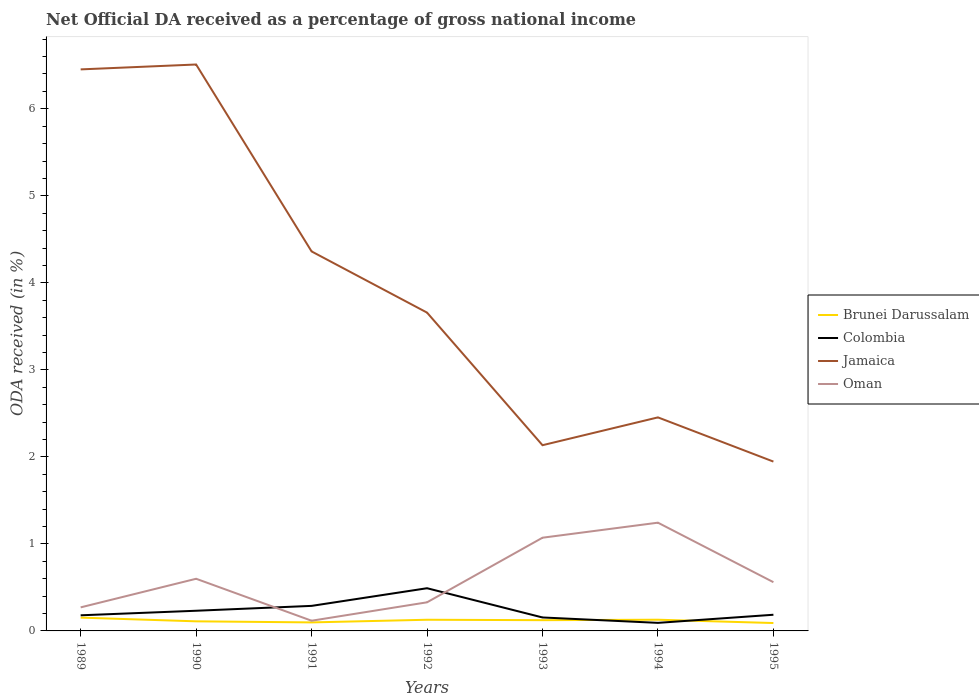How many different coloured lines are there?
Keep it short and to the point. 4. Does the line corresponding to Jamaica intersect with the line corresponding to Colombia?
Your answer should be very brief. No. Across all years, what is the maximum net official DA received in Jamaica?
Provide a succinct answer. 1.95. What is the total net official DA received in Jamaica in the graph?
Offer a terse response. 1.2. What is the difference between the highest and the second highest net official DA received in Brunei Darussalam?
Your answer should be compact. 0.06. What is the difference between the highest and the lowest net official DA received in Brunei Darussalam?
Your answer should be very brief. 4. How many lines are there?
Your answer should be very brief. 4. Does the graph contain any zero values?
Your response must be concise. No. Where does the legend appear in the graph?
Offer a terse response. Center right. What is the title of the graph?
Your answer should be very brief. Net Official DA received as a percentage of gross national income. Does "Armenia" appear as one of the legend labels in the graph?
Give a very brief answer. No. What is the label or title of the Y-axis?
Your response must be concise. ODA received (in %). What is the ODA received (in %) of Brunei Darussalam in 1989?
Your answer should be very brief. 0.15. What is the ODA received (in %) in Colombia in 1989?
Make the answer very short. 0.18. What is the ODA received (in %) in Jamaica in 1989?
Ensure brevity in your answer.  6.45. What is the ODA received (in %) of Oman in 1989?
Provide a succinct answer. 0.27. What is the ODA received (in %) of Brunei Darussalam in 1990?
Give a very brief answer. 0.11. What is the ODA received (in %) in Colombia in 1990?
Ensure brevity in your answer.  0.23. What is the ODA received (in %) in Jamaica in 1990?
Provide a short and direct response. 6.51. What is the ODA received (in %) of Oman in 1990?
Your response must be concise. 0.6. What is the ODA received (in %) in Brunei Darussalam in 1991?
Your answer should be compact. 0.1. What is the ODA received (in %) of Colombia in 1991?
Your response must be concise. 0.29. What is the ODA received (in %) in Jamaica in 1991?
Your answer should be very brief. 4.36. What is the ODA received (in %) in Oman in 1991?
Give a very brief answer. 0.12. What is the ODA received (in %) of Brunei Darussalam in 1992?
Keep it short and to the point. 0.13. What is the ODA received (in %) of Colombia in 1992?
Your response must be concise. 0.49. What is the ODA received (in %) of Jamaica in 1992?
Give a very brief answer. 3.66. What is the ODA received (in %) in Oman in 1992?
Provide a succinct answer. 0.33. What is the ODA received (in %) in Brunei Darussalam in 1993?
Give a very brief answer. 0.12. What is the ODA received (in %) of Colombia in 1993?
Make the answer very short. 0.15. What is the ODA received (in %) of Jamaica in 1993?
Offer a terse response. 2.13. What is the ODA received (in %) of Oman in 1993?
Provide a short and direct response. 1.07. What is the ODA received (in %) in Brunei Darussalam in 1994?
Offer a terse response. 0.13. What is the ODA received (in %) in Colombia in 1994?
Offer a very short reply. 0.09. What is the ODA received (in %) of Jamaica in 1994?
Your response must be concise. 2.45. What is the ODA received (in %) in Oman in 1994?
Your response must be concise. 1.24. What is the ODA received (in %) in Brunei Darussalam in 1995?
Keep it short and to the point. 0.09. What is the ODA received (in %) of Colombia in 1995?
Your response must be concise. 0.19. What is the ODA received (in %) of Jamaica in 1995?
Provide a succinct answer. 1.95. What is the ODA received (in %) in Oman in 1995?
Offer a very short reply. 0.56. Across all years, what is the maximum ODA received (in %) in Brunei Darussalam?
Offer a very short reply. 0.15. Across all years, what is the maximum ODA received (in %) of Colombia?
Offer a very short reply. 0.49. Across all years, what is the maximum ODA received (in %) in Jamaica?
Ensure brevity in your answer.  6.51. Across all years, what is the maximum ODA received (in %) in Oman?
Your response must be concise. 1.24. Across all years, what is the minimum ODA received (in %) in Brunei Darussalam?
Offer a very short reply. 0.09. Across all years, what is the minimum ODA received (in %) of Colombia?
Ensure brevity in your answer.  0.09. Across all years, what is the minimum ODA received (in %) in Jamaica?
Provide a succinct answer. 1.95. Across all years, what is the minimum ODA received (in %) in Oman?
Keep it short and to the point. 0.12. What is the total ODA received (in %) of Brunei Darussalam in the graph?
Ensure brevity in your answer.  0.83. What is the total ODA received (in %) of Colombia in the graph?
Give a very brief answer. 1.62. What is the total ODA received (in %) in Jamaica in the graph?
Your answer should be very brief. 27.51. What is the total ODA received (in %) of Oman in the graph?
Ensure brevity in your answer.  4.19. What is the difference between the ODA received (in %) of Brunei Darussalam in 1989 and that in 1990?
Your answer should be compact. 0.04. What is the difference between the ODA received (in %) in Colombia in 1989 and that in 1990?
Offer a very short reply. -0.05. What is the difference between the ODA received (in %) in Jamaica in 1989 and that in 1990?
Provide a succinct answer. -0.06. What is the difference between the ODA received (in %) in Oman in 1989 and that in 1990?
Keep it short and to the point. -0.33. What is the difference between the ODA received (in %) in Brunei Darussalam in 1989 and that in 1991?
Offer a terse response. 0.05. What is the difference between the ODA received (in %) of Colombia in 1989 and that in 1991?
Keep it short and to the point. -0.11. What is the difference between the ODA received (in %) of Jamaica in 1989 and that in 1991?
Offer a very short reply. 2.09. What is the difference between the ODA received (in %) in Oman in 1989 and that in 1991?
Keep it short and to the point. 0.15. What is the difference between the ODA received (in %) of Brunei Darussalam in 1989 and that in 1992?
Offer a terse response. 0.02. What is the difference between the ODA received (in %) of Colombia in 1989 and that in 1992?
Keep it short and to the point. -0.31. What is the difference between the ODA received (in %) in Jamaica in 1989 and that in 1992?
Ensure brevity in your answer.  2.79. What is the difference between the ODA received (in %) of Oman in 1989 and that in 1992?
Your answer should be very brief. -0.06. What is the difference between the ODA received (in %) in Brunei Darussalam in 1989 and that in 1993?
Keep it short and to the point. 0.03. What is the difference between the ODA received (in %) of Colombia in 1989 and that in 1993?
Provide a short and direct response. 0.02. What is the difference between the ODA received (in %) of Jamaica in 1989 and that in 1993?
Your response must be concise. 4.32. What is the difference between the ODA received (in %) of Oman in 1989 and that in 1993?
Your response must be concise. -0.8. What is the difference between the ODA received (in %) in Brunei Darussalam in 1989 and that in 1994?
Ensure brevity in your answer.  0.02. What is the difference between the ODA received (in %) of Colombia in 1989 and that in 1994?
Your answer should be compact. 0.09. What is the difference between the ODA received (in %) in Jamaica in 1989 and that in 1994?
Provide a short and direct response. 4. What is the difference between the ODA received (in %) of Oman in 1989 and that in 1994?
Provide a short and direct response. -0.97. What is the difference between the ODA received (in %) in Brunei Darussalam in 1989 and that in 1995?
Provide a short and direct response. 0.06. What is the difference between the ODA received (in %) in Colombia in 1989 and that in 1995?
Your answer should be compact. -0.01. What is the difference between the ODA received (in %) of Jamaica in 1989 and that in 1995?
Offer a very short reply. 4.51. What is the difference between the ODA received (in %) of Oman in 1989 and that in 1995?
Ensure brevity in your answer.  -0.29. What is the difference between the ODA received (in %) in Brunei Darussalam in 1990 and that in 1991?
Provide a succinct answer. 0.01. What is the difference between the ODA received (in %) of Colombia in 1990 and that in 1991?
Your answer should be compact. -0.06. What is the difference between the ODA received (in %) of Jamaica in 1990 and that in 1991?
Keep it short and to the point. 2.15. What is the difference between the ODA received (in %) of Oman in 1990 and that in 1991?
Your answer should be compact. 0.48. What is the difference between the ODA received (in %) of Brunei Darussalam in 1990 and that in 1992?
Give a very brief answer. -0.02. What is the difference between the ODA received (in %) in Colombia in 1990 and that in 1992?
Your response must be concise. -0.26. What is the difference between the ODA received (in %) of Jamaica in 1990 and that in 1992?
Your answer should be very brief. 2.85. What is the difference between the ODA received (in %) in Oman in 1990 and that in 1992?
Your response must be concise. 0.27. What is the difference between the ODA received (in %) of Brunei Darussalam in 1990 and that in 1993?
Ensure brevity in your answer.  -0.01. What is the difference between the ODA received (in %) of Colombia in 1990 and that in 1993?
Offer a very short reply. 0.08. What is the difference between the ODA received (in %) of Jamaica in 1990 and that in 1993?
Your response must be concise. 4.37. What is the difference between the ODA received (in %) in Oman in 1990 and that in 1993?
Make the answer very short. -0.47. What is the difference between the ODA received (in %) of Brunei Darussalam in 1990 and that in 1994?
Make the answer very short. -0.02. What is the difference between the ODA received (in %) in Colombia in 1990 and that in 1994?
Your response must be concise. 0.14. What is the difference between the ODA received (in %) of Jamaica in 1990 and that in 1994?
Offer a very short reply. 4.06. What is the difference between the ODA received (in %) of Oman in 1990 and that in 1994?
Offer a terse response. -0.64. What is the difference between the ODA received (in %) of Brunei Darussalam in 1990 and that in 1995?
Provide a short and direct response. 0.02. What is the difference between the ODA received (in %) of Colombia in 1990 and that in 1995?
Offer a terse response. 0.05. What is the difference between the ODA received (in %) of Jamaica in 1990 and that in 1995?
Ensure brevity in your answer.  4.56. What is the difference between the ODA received (in %) in Oman in 1990 and that in 1995?
Make the answer very short. 0.04. What is the difference between the ODA received (in %) in Brunei Darussalam in 1991 and that in 1992?
Offer a very short reply. -0.03. What is the difference between the ODA received (in %) in Colombia in 1991 and that in 1992?
Your answer should be compact. -0.2. What is the difference between the ODA received (in %) of Jamaica in 1991 and that in 1992?
Your answer should be compact. 0.7. What is the difference between the ODA received (in %) in Oman in 1991 and that in 1992?
Your answer should be very brief. -0.21. What is the difference between the ODA received (in %) in Brunei Darussalam in 1991 and that in 1993?
Keep it short and to the point. -0.03. What is the difference between the ODA received (in %) of Colombia in 1991 and that in 1993?
Ensure brevity in your answer.  0.13. What is the difference between the ODA received (in %) in Jamaica in 1991 and that in 1993?
Your response must be concise. 2.23. What is the difference between the ODA received (in %) in Oman in 1991 and that in 1993?
Your response must be concise. -0.95. What is the difference between the ODA received (in %) of Brunei Darussalam in 1991 and that in 1994?
Offer a very short reply. -0.03. What is the difference between the ODA received (in %) in Colombia in 1991 and that in 1994?
Your answer should be compact. 0.2. What is the difference between the ODA received (in %) of Jamaica in 1991 and that in 1994?
Make the answer very short. 1.91. What is the difference between the ODA received (in %) in Oman in 1991 and that in 1994?
Provide a succinct answer. -1.13. What is the difference between the ODA received (in %) of Brunei Darussalam in 1991 and that in 1995?
Give a very brief answer. 0.01. What is the difference between the ODA received (in %) of Colombia in 1991 and that in 1995?
Offer a terse response. 0.1. What is the difference between the ODA received (in %) of Jamaica in 1991 and that in 1995?
Give a very brief answer. 2.42. What is the difference between the ODA received (in %) of Oman in 1991 and that in 1995?
Provide a succinct answer. -0.44. What is the difference between the ODA received (in %) of Brunei Darussalam in 1992 and that in 1993?
Provide a short and direct response. 0. What is the difference between the ODA received (in %) in Colombia in 1992 and that in 1993?
Your answer should be very brief. 0.34. What is the difference between the ODA received (in %) in Jamaica in 1992 and that in 1993?
Offer a very short reply. 1.52. What is the difference between the ODA received (in %) of Oman in 1992 and that in 1993?
Give a very brief answer. -0.74. What is the difference between the ODA received (in %) of Brunei Darussalam in 1992 and that in 1994?
Give a very brief answer. -0. What is the difference between the ODA received (in %) in Colombia in 1992 and that in 1994?
Give a very brief answer. 0.4. What is the difference between the ODA received (in %) of Jamaica in 1992 and that in 1994?
Your answer should be very brief. 1.2. What is the difference between the ODA received (in %) of Oman in 1992 and that in 1994?
Your response must be concise. -0.92. What is the difference between the ODA received (in %) of Brunei Darussalam in 1992 and that in 1995?
Provide a short and direct response. 0.04. What is the difference between the ODA received (in %) in Colombia in 1992 and that in 1995?
Provide a succinct answer. 0.3. What is the difference between the ODA received (in %) of Jamaica in 1992 and that in 1995?
Make the answer very short. 1.71. What is the difference between the ODA received (in %) of Oman in 1992 and that in 1995?
Your answer should be compact. -0.23. What is the difference between the ODA received (in %) of Brunei Darussalam in 1993 and that in 1994?
Your answer should be compact. -0.01. What is the difference between the ODA received (in %) of Colombia in 1993 and that in 1994?
Make the answer very short. 0.06. What is the difference between the ODA received (in %) in Jamaica in 1993 and that in 1994?
Provide a short and direct response. -0.32. What is the difference between the ODA received (in %) in Oman in 1993 and that in 1994?
Keep it short and to the point. -0.17. What is the difference between the ODA received (in %) of Brunei Darussalam in 1993 and that in 1995?
Your response must be concise. 0.03. What is the difference between the ODA received (in %) of Colombia in 1993 and that in 1995?
Your answer should be compact. -0.03. What is the difference between the ODA received (in %) of Jamaica in 1993 and that in 1995?
Your answer should be compact. 0.19. What is the difference between the ODA received (in %) of Oman in 1993 and that in 1995?
Offer a terse response. 0.51. What is the difference between the ODA received (in %) in Brunei Darussalam in 1994 and that in 1995?
Ensure brevity in your answer.  0.04. What is the difference between the ODA received (in %) in Colombia in 1994 and that in 1995?
Keep it short and to the point. -0.09. What is the difference between the ODA received (in %) of Jamaica in 1994 and that in 1995?
Provide a short and direct response. 0.51. What is the difference between the ODA received (in %) of Oman in 1994 and that in 1995?
Provide a short and direct response. 0.68. What is the difference between the ODA received (in %) of Brunei Darussalam in 1989 and the ODA received (in %) of Colombia in 1990?
Ensure brevity in your answer.  -0.08. What is the difference between the ODA received (in %) of Brunei Darussalam in 1989 and the ODA received (in %) of Jamaica in 1990?
Give a very brief answer. -6.36. What is the difference between the ODA received (in %) of Brunei Darussalam in 1989 and the ODA received (in %) of Oman in 1990?
Offer a very short reply. -0.45. What is the difference between the ODA received (in %) in Colombia in 1989 and the ODA received (in %) in Jamaica in 1990?
Keep it short and to the point. -6.33. What is the difference between the ODA received (in %) in Colombia in 1989 and the ODA received (in %) in Oman in 1990?
Your answer should be compact. -0.42. What is the difference between the ODA received (in %) of Jamaica in 1989 and the ODA received (in %) of Oman in 1990?
Your answer should be compact. 5.85. What is the difference between the ODA received (in %) of Brunei Darussalam in 1989 and the ODA received (in %) of Colombia in 1991?
Give a very brief answer. -0.14. What is the difference between the ODA received (in %) of Brunei Darussalam in 1989 and the ODA received (in %) of Jamaica in 1991?
Your answer should be compact. -4.21. What is the difference between the ODA received (in %) in Brunei Darussalam in 1989 and the ODA received (in %) in Oman in 1991?
Ensure brevity in your answer.  0.04. What is the difference between the ODA received (in %) in Colombia in 1989 and the ODA received (in %) in Jamaica in 1991?
Your answer should be very brief. -4.18. What is the difference between the ODA received (in %) of Colombia in 1989 and the ODA received (in %) of Oman in 1991?
Give a very brief answer. 0.06. What is the difference between the ODA received (in %) of Jamaica in 1989 and the ODA received (in %) of Oman in 1991?
Give a very brief answer. 6.34. What is the difference between the ODA received (in %) of Brunei Darussalam in 1989 and the ODA received (in %) of Colombia in 1992?
Provide a short and direct response. -0.34. What is the difference between the ODA received (in %) in Brunei Darussalam in 1989 and the ODA received (in %) in Jamaica in 1992?
Give a very brief answer. -3.51. What is the difference between the ODA received (in %) in Brunei Darussalam in 1989 and the ODA received (in %) in Oman in 1992?
Ensure brevity in your answer.  -0.18. What is the difference between the ODA received (in %) of Colombia in 1989 and the ODA received (in %) of Jamaica in 1992?
Make the answer very short. -3.48. What is the difference between the ODA received (in %) of Colombia in 1989 and the ODA received (in %) of Oman in 1992?
Your answer should be compact. -0.15. What is the difference between the ODA received (in %) in Jamaica in 1989 and the ODA received (in %) in Oman in 1992?
Give a very brief answer. 6.12. What is the difference between the ODA received (in %) in Brunei Darussalam in 1989 and the ODA received (in %) in Colombia in 1993?
Offer a very short reply. -0. What is the difference between the ODA received (in %) in Brunei Darussalam in 1989 and the ODA received (in %) in Jamaica in 1993?
Provide a short and direct response. -1.98. What is the difference between the ODA received (in %) of Brunei Darussalam in 1989 and the ODA received (in %) of Oman in 1993?
Provide a succinct answer. -0.92. What is the difference between the ODA received (in %) of Colombia in 1989 and the ODA received (in %) of Jamaica in 1993?
Make the answer very short. -1.95. What is the difference between the ODA received (in %) of Colombia in 1989 and the ODA received (in %) of Oman in 1993?
Make the answer very short. -0.89. What is the difference between the ODA received (in %) in Jamaica in 1989 and the ODA received (in %) in Oman in 1993?
Your response must be concise. 5.38. What is the difference between the ODA received (in %) of Brunei Darussalam in 1989 and the ODA received (in %) of Colombia in 1994?
Your answer should be compact. 0.06. What is the difference between the ODA received (in %) in Brunei Darussalam in 1989 and the ODA received (in %) in Jamaica in 1994?
Offer a terse response. -2.3. What is the difference between the ODA received (in %) of Brunei Darussalam in 1989 and the ODA received (in %) of Oman in 1994?
Your answer should be compact. -1.09. What is the difference between the ODA received (in %) in Colombia in 1989 and the ODA received (in %) in Jamaica in 1994?
Ensure brevity in your answer.  -2.27. What is the difference between the ODA received (in %) in Colombia in 1989 and the ODA received (in %) in Oman in 1994?
Your answer should be very brief. -1.06. What is the difference between the ODA received (in %) in Jamaica in 1989 and the ODA received (in %) in Oman in 1994?
Provide a short and direct response. 5.21. What is the difference between the ODA received (in %) of Brunei Darussalam in 1989 and the ODA received (in %) of Colombia in 1995?
Keep it short and to the point. -0.03. What is the difference between the ODA received (in %) of Brunei Darussalam in 1989 and the ODA received (in %) of Jamaica in 1995?
Ensure brevity in your answer.  -1.79. What is the difference between the ODA received (in %) of Brunei Darussalam in 1989 and the ODA received (in %) of Oman in 1995?
Your answer should be compact. -0.41. What is the difference between the ODA received (in %) of Colombia in 1989 and the ODA received (in %) of Jamaica in 1995?
Give a very brief answer. -1.77. What is the difference between the ODA received (in %) in Colombia in 1989 and the ODA received (in %) in Oman in 1995?
Your answer should be compact. -0.38. What is the difference between the ODA received (in %) of Jamaica in 1989 and the ODA received (in %) of Oman in 1995?
Offer a very short reply. 5.89. What is the difference between the ODA received (in %) of Brunei Darussalam in 1990 and the ODA received (in %) of Colombia in 1991?
Your answer should be compact. -0.18. What is the difference between the ODA received (in %) of Brunei Darussalam in 1990 and the ODA received (in %) of Jamaica in 1991?
Give a very brief answer. -4.25. What is the difference between the ODA received (in %) of Brunei Darussalam in 1990 and the ODA received (in %) of Oman in 1991?
Your answer should be very brief. -0.01. What is the difference between the ODA received (in %) of Colombia in 1990 and the ODA received (in %) of Jamaica in 1991?
Make the answer very short. -4.13. What is the difference between the ODA received (in %) in Colombia in 1990 and the ODA received (in %) in Oman in 1991?
Your answer should be compact. 0.11. What is the difference between the ODA received (in %) in Jamaica in 1990 and the ODA received (in %) in Oman in 1991?
Keep it short and to the point. 6.39. What is the difference between the ODA received (in %) in Brunei Darussalam in 1990 and the ODA received (in %) in Colombia in 1992?
Your response must be concise. -0.38. What is the difference between the ODA received (in %) of Brunei Darussalam in 1990 and the ODA received (in %) of Jamaica in 1992?
Offer a terse response. -3.55. What is the difference between the ODA received (in %) in Brunei Darussalam in 1990 and the ODA received (in %) in Oman in 1992?
Make the answer very short. -0.22. What is the difference between the ODA received (in %) of Colombia in 1990 and the ODA received (in %) of Jamaica in 1992?
Offer a very short reply. -3.43. What is the difference between the ODA received (in %) in Colombia in 1990 and the ODA received (in %) in Oman in 1992?
Provide a short and direct response. -0.1. What is the difference between the ODA received (in %) in Jamaica in 1990 and the ODA received (in %) in Oman in 1992?
Ensure brevity in your answer.  6.18. What is the difference between the ODA received (in %) in Brunei Darussalam in 1990 and the ODA received (in %) in Colombia in 1993?
Provide a succinct answer. -0.04. What is the difference between the ODA received (in %) of Brunei Darussalam in 1990 and the ODA received (in %) of Jamaica in 1993?
Your answer should be very brief. -2.02. What is the difference between the ODA received (in %) of Brunei Darussalam in 1990 and the ODA received (in %) of Oman in 1993?
Ensure brevity in your answer.  -0.96. What is the difference between the ODA received (in %) in Colombia in 1990 and the ODA received (in %) in Jamaica in 1993?
Provide a short and direct response. -1.9. What is the difference between the ODA received (in %) of Colombia in 1990 and the ODA received (in %) of Oman in 1993?
Give a very brief answer. -0.84. What is the difference between the ODA received (in %) of Jamaica in 1990 and the ODA received (in %) of Oman in 1993?
Keep it short and to the point. 5.44. What is the difference between the ODA received (in %) of Brunei Darussalam in 1990 and the ODA received (in %) of Colombia in 1994?
Provide a short and direct response. 0.02. What is the difference between the ODA received (in %) in Brunei Darussalam in 1990 and the ODA received (in %) in Jamaica in 1994?
Keep it short and to the point. -2.34. What is the difference between the ODA received (in %) of Brunei Darussalam in 1990 and the ODA received (in %) of Oman in 1994?
Provide a succinct answer. -1.13. What is the difference between the ODA received (in %) in Colombia in 1990 and the ODA received (in %) in Jamaica in 1994?
Keep it short and to the point. -2.22. What is the difference between the ODA received (in %) in Colombia in 1990 and the ODA received (in %) in Oman in 1994?
Provide a short and direct response. -1.01. What is the difference between the ODA received (in %) in Jamaica in 1990 and the ODA received (in %) in Oman in 1994?
Give a very brief answer. 5.27. What is the difference between the ODA received (in %) in Brunei Darussalam in 1990 and the ODA received (in %) in Colombia in 1995?
Offer a terse response. -0.08. What is the difference between the ODA received (in %) of Brunei Darussalam in 1990 and the ODA received (in %) of Jamaica in 1995?
Make the answer very short. -1.84. What is the difference between the ODA received (in %) in Brunei Darussalam in 1990 and the ODA received (in %) in Oman in 1995?
Your answer should be compact. -0.45. What is the difference between the ODA received (in %) in Colombia in 1990 and the ODA received (in %) in Jamaica in 1995?
Provide a succinct answer. -1.71. What is the difference between the ODA received (in %) of Colombia in 1990 and the ODA received (in %) of Oman in 1995?
Keep it short and to the point. -0.33. What is the difference between the ODA received (in %) in Jamaica in 1990 and the ODA received (in %) in Oman in 1995?
Give a very brief answer. 5.95. What is the difference between the ODA received (in %) in Brunei Darussalam in 1991 and the ODA received (in %) in Colombia in 1992?
Offer a terse response. -0.39. What is the difference between the ODA received (in %) in Brunei Darussalam in 1991 and the ODA received (in %) in Jamaica in 1992?
Give a very brief answer. -3.56. What is the difference between the ODA received (in %) in Brunei Darussalam in 1991 and the ODA received (in %) in Oman in 1992?
Your answer should be very brief. -0.23. What is the difference between the ODA received (in %) of Colombia in 1991 and the ODA received (in %) of Jamaica in 1992?
Make the answer very short. -3.37. What is the difference between the ODA received (in %) in Colombia in 1991 and the ODA received (in %) in Oman in 1992?
Offer a terse response. -0.04. What is the difference between the ODA received (in %) in Jamaica in 1991 and the ODA received (in %) in Oman in 1992?
Provide a succinct answer. 4.03. What is the difference between the ODA received (in %) in Brunei Darussalam in 1991 and the ODA received (in %) in Colombia in 1993?
Your response must be concise. -0.06. What is the difference between the ODA received (in %) of Brunei Darussalam in 1991 and the ODA received (in %) of Jamaica in 1993?
Your response must be concise. -2.04. What is the difference between the ODA received (in %) in Brunei Darussalam in 1991 and the ODA received (in %) in Oman in 1993?
Your answer should be compact. -0.97. What is the difference between the ODA received (in %) in Colombia in 1991 and the ODA received (in %) in Jamaica in 1993?
Provide a succinct answer. -1.85. What is the difference between the ODA received (in %) in Colombia in 1991 and the ODA received (in %) in Oman in 1993?
Your answer should be compact. -0.78. What is the difference between the ODA received (in %) in Jamaica in 1991 and the ODA received (in %) in Oman in 1993?
Provide a short and direct response. 3.29. What is the difference between the ODA received (in %) in Brunei Darussalam in 1991 and the ODA received (in %) in Colombia in 1994?
Provide a short and direct response. 0.01. What is the difference between the ODA received (in %) of Brunei Darussalam in 1991 and the ODA received (in %) of Jamaica in 1994?
Offer a terse response. -2.36. What is the difference between the ODA received (in %) of Brunei Darussalam in 1991 and the ODA received (in %) of Oman in 1994?
Make the answer very short. -1.15. What is the difference between the ODA received (in %) in Colombia in 1991 and the ODA received (in %) in Jamaica in 1994?
Offer a very short reply. -2.17. What is the difference between the ODA received (in %) of Colombia in 1991 and the ODA received (in %) of Oman in 1994?
Provide a succinct answer. -0.96. What is the difference between the ODA received (in %) of Jamaica in 1991 and the ODA received (in %) of Oman in 1994?
Provide a succinct answer. 3.12. What is the difference between the ODA received (in %) in Brunei Darussalam in 1991 and the ODA received (in %) in Colombia in 1995?
Give a very brief answer. -0.09. What is the difference between the ODA received (in %) in Brunei Darussalam in 1991 and the ODA received (in %) in Jamaica in 1995?
Offer a very short reply. -1.85. What is the difference between the ODA received (in %) of Brunei Darussalam in 1991 and the ODA received (in %) of Oman in 1995?
Give a very brief answer. -0.46. What is the difference between the ODA received (in %) in Colombia in 1991 and the ODA received (in %) in Jamaica in 1995?
Your answer should be very brief. -1.66. What is the difference between the ODA received (in %) of Colombia in 1991 and the ODA received (in %) of Oman in 1995?
Give a very brief answer. -0.27. What is the difference between the ODA received (in %) of Jamaica in 1991 and the ODA received (in %) of Oman in 1995?
Give a very brief answer. 3.8. What is the difference between the ODA received (in %) of Brunei Darussalam in 1992 and the ODA received (in %) of Colombia in 1993?
Ensure brevity in your answer.  -0.03. What is the difference between the ODA received (in %) in Brunei Darussalam in 1992 and the ODA received (in %) in Jamaica in 1993?
Your answer should be very brief. -2.01. What is the difference between the ODA received (in %) in Brunei Darussalam in 1992 and the ODA received (in %) in Oman in 1993?
Keep it short and to the point. -0.94. What is the difference between the ODA received (in %) in Colombia in 1992 and the ODA received (in %) in Jamaica in 1993?
Offer a very short reply. -1.64. What is the difference between the ODA received (in %) of Colombia in 1992 and the ODA received (in %) of Oman in 1993?
Provide a short and direct response. -0.58. What is the difference between the ODA received (in %) of Jamaica in 1992 and the ODA received (in %) of Oman in 1993?
Give a very brief answer. 2.59. What is the difference between the ODA received (in %) of Brunei Darussalam in 1992 and the ODA received (in %) of Colombia in 1994?
Keep it short and to the point. 0.04. What is the difference between the ODA received (in %) of Brunei Darussalam in 1992 and the ODA received (in %) of Jamaica in 1994?
Your answer should be compact. -2.33. What is the difference between the ODA received (in %) in Brunei Darussalam in 1992 and the ODA received (in %) in Oman in 1994?
Your answer should be very brief. -1.12. What is the difference between the ODA received (in %) in Colombia in 1992 and the ODA received (in %) in Jamaica in 1994?
Offer a very short reply. -1.96. What is the difference between the ODA received (in %) in Colombia in 1992 and the ODA received (in %) in Oman in 1994?
Give a very brief answer. -0.75. What is the difference between the ODA received (in %) of Jamaica in 1992 and the ODA received (in %) of Oman in 1994?
Keep it short and to the point. 2.41. What is the difference between the ODA received (in %) in Brunei Darussalam in 1992 and the ODA received (in %) in Colombia in 1995?
Provide a succinct answer. -0.06. What is the difference between the ODA received (in %) of Brunei Darussalam in 1992 and the ODA received (in %) of Jamaica in 1995?
Keep it short and to the point. -1.82. What is the difference between the ODA received (in %) in Brunei Darussalam in 1992 and the ODA received (in %) in Oman in 1995?
Make the answer very short. -0.43. What is the difference between the ODA received (in %) of Colombia in 1992 and the ODA received (in %) of Jamaica in 1995?
Provide a short and direct response. -1.46. What is the difference between the ODA received (in %) in Colombia in 1992 and the ODA received (in %) in Oman in 1995?
Ensure brevity in your answer.  -0.07. What is the difference between the ODA received (in %) in Jamaica in 1992 and the ODA received (in %) in Oman in 1995?
Provide a short and direct response. 3.1. What is the difference between the ODA received (in %) in Brunei Darussalam in 1993 and the ODA received (in %) in Colombia in 1994?
Give a very brief answer. 0.03. What is the difference between the ODA received (in %) in Brunei Darussalam in 1993 and the ODA received (in %) in Jamaica in 1994?
Give a very brief answer. -2.33. What is the difference between the ODA received (in %) in Brunei Darussalam in 1993 and the ODA received (in %) in Oman in 1994?
Your answer should be compact. -1.12. What is the difference between the ODA received (in %) in Colombia in 1993 and the ODA received (in %) in Jamaica in 1994?
Offer a terse response. -2.3. What is the difference between the ODA received (in %) in Colombia in 1993 and the ODA received (in %) in Oman in 1994?
Give a very brief answer. -1.09. What is the difference between the ODA received (in %) of Jamaica in 1993 and the ODA received (in %) of Oman in 1994?
Ensure brevity in your answer.  0.89. What is the difference between the ODA received (in %) of Brunei Darussalam in 1993 and the ODA received (in %) of Colombia in 1995?
Your response must be concise. -0.06. What is the difference between the ODA received (in %) of Brunei Darussalam in 1993 and the ODA received (in %) of Jamaica in 1995?
Keep it short and to the point. -1.82. What is the difference between the ODA received (in %) in Brunei Darussalam in 1993 and the ODA received (in %) in Oman in 1995?
Give a very brief answer. -0.44. What is the difference between the ODA received (in %) of Colombia in 1993 and the ODA received (in %) of Jamaica in 1995?
Make the answer very short. -1.79. What is the difference between the ODA received (in %) in Colombia in 1993 and the ODA received (in %) in Oman in 1995?
Your response must be concise. -0.41. What is the difference between the ODA received (in %) in Jamaica in 1993 and the ODA received (in %) in Oman in 1995?
Provide a short and direct response. 1.57. What is the difference between the ODA received (in %) of Brunei Darussalam in 1994 and the ODA received (in %) of Colombia in 1995?
Provide a short and direct response. -0.06. What is the difference between the ODA received (in %) of Brunei Darussalam in 1994 and the ODA received (in %) of Jamaica in 1995?
Your answer should be very brief. -1.82. What is the difference between the ODA received (in %) in Brunei Darussalam in 1994 and the ODA received (in %) in Oman in 1995?
Offer a very short reply. -0.43. What is the difference between the ODA received (in %) of Colombia in 1994 and the ODA received (in %) of Jamaica in 1995?
Your response must be concise. -1.85. What is the difference between the ODA received (in %) in Colombia in 1994 and the ODA received (in %) in Oman in 1995?
Provide a succinct answer. -0.47. What is the difference between the ODA received (in %) in Jamaica in 1994 and the ODA received (in %) in Oman in 1995?
Provide a succinct answer. 1.89. What is the average ODA received (in %) of Brunei Darussalam per year?
Provide a short and direct response. 0.12. What is the average ODA received (in %) of Colombia per year?
Your answer should be very brief. 0.23. What is the average ODA received (in %) in Jamaica per year?
Ensure brevity in your answer.  3.93. What is the average ODA received (in %) of Oman per year?
Offer a terse response. 0.6. In the year 1989, what is the difference between the ODA received (in %) of Brunei Darussalam and ODA received (in %) of Colombia?
Ensure brevity in your answer.  -0.03. In the year 1989, what is the difference between the ODA received (in %) in Brunei Darussalam and ODA received (in %) in Jamaica?
Offer a terse response. -6.3. In the year 1989, what is the difference between the ODA received (in %) of Brunei Darussalam and ODA received (in %) of Oman?
Keep it short and to the point. -0.12. In the year 1989, what is the difference between the ODA received (in %) in Colombia and ODA received (in %) in Jamaica?
Your response must be concise. -6.27. In the year 1989, what is the difference between the ODA received (in %) of Colombia and ODA received (in %) of Oman?
Make the answer very short. -0.09. In the year 1989, what is the difference between the ODA received (in %) of Jamaica and ODA received (in %) of Oman?
Keep it short and to the point. 6.18. In the year 1990, what is the difference between the ODA received (in %) in Brunei Darussalam and ODA received (in %) in Colombia?
Your response must be concise. -0.12. In the year 1990, what is the difference between the ODA received (in %) in Brunei Darussalam and ODA received (in %) in Jamaica?
Give a very brief answer. -6.4. In the year 1990, what is the difference between the ODA received (in %) of Brunei Darussalam and ODA received (in %) of Oman?
Your answer should be very brief. -0.49. In the year 1990, what is the difference between the ODA received (in %) in Colombia and ODA received (in %) in Jamaica?
Provide a succinct answer. -6.28. In the year 1990, what is the difference between the ODA received (in %) of Colombia and ODA received (in %) of Oman?
Your answer should be compact. -0.37. In the year 1990, what is the difference between the ODA received (in %) in Jamaica and ODA received (in %) in Oman?
Ensure brevity in your answer.  5.91. In the year 1991, what is the difference between the ODA received (in %) of Brunei Darussalam and ODA received (in %) of Colombia?
Your answer should be very brief. -0.19. In the year 1991, what is the difference between the ODA received (in %) in Brunei Darussalam and ODA received (in %) in Jamaica?
Your response must be concise. -4.26. In the year 1991, what is the difference between the ODA received (in %) of Brunei Darussalam and ODA received (in %) of Oman?
Your response must be concise. -0.02. In the year 1991, what is the difference between the ODA received (in %) of Colombia and ODA received (in %) of Jamaica?
Keep it short and to the point. -4.07. In the year 1991, what is the difference between the ODA received (in %) in Colombia and ODA received (in %) in Oman?
Provide a short and direct response. 0.17. In the year 1991, what is the difference between the ODA received (in %) of Jamaica and ODA received (in %) of Oman?
Provide a short and direct response. 4.24. In the year 1992, what is the difference between the ODA received (in %) in Brunei Darussalam and ODA received (in %) in Colombia?
Your answer should be compact. -0.36. In the year 1992, what is the difference between the ODA received (in %) of Brunei Darussalam and ODA received (in %) of Jamaica?
Keep it short and to the point. -3.53. In the year 1992, what is the difference between the ODA received (in %) of Brunei Darussalam and ODA received (in %) of Oman?
Give a very brief answer. -0.2. In the year 1992, what is the difference between the ODA received (in %) in Colombia and ODA received (in %) in Jamaica?
Your answer should be compact. -3.17. In the year 1992, what is the difference between the ODA received (in %) of Colombia and ODA received (in %) of Oman?
Offer a terse response. 0.16. In the year 1992, what is the difference between the ODA received (in %) in Jamaica and ODA received (in %) in Oman?
Your answer should be very brief. 3.33. In the year 1993, what is the difference between the ODA received (in %) of Brunei Darussalam and ODA received (in %) of Colombia?
Offer a very short reply. -0.03. In the year 1993, what is the difference between the ODA received (in %) in Brunei Darussalam and ODA received (in %) in Jamaica?
Offer a terse response. -2.01. In the year 1993, what is the difference between the ODA received (in %) of Brunei Darussalam and ODA received (in %) of Oman?
Give a very brief answer. -0.95. In the year 1993, what is the difference between the ODA received (in %) of Colombia and ODA received (in %) of Jamaica?
Your answer should be compact. -1.98. In the year 1993, what is the difference between the ODA received (in %) of Colombia and ODA received (in %) of Oman?
Your response must be concise. -0.92. In the year 1993, what is the difference between the ODA received (in %) of Jamaica and ODA received (in %) of Oman?
Provide a succinct answer. 1.06. In the year 1994, what is the difference between the ODA received (in %) in Brunei Darussalam and ODA received (in %) in Colombia?
Ensure brevity in your answer.  0.04. In the year 1994, what is the difference between the ODA received (in %) in Brunei Darussalam and ODA received (in %) in Jamaica?
Keep it short and to the point. -2.33. In the year 1994, what is the difference between the ODA received (in %) of Brunei Darussalam and ODA received (in %) of Oman?
Provide a succinct answer. -1.12. In the year 1994, what is the difference between the ODA received (in %) of Colombia and ODA received (in %) of Jamaica?
Your answer should be very brief. -2.36. In the year 1994, what is the difference between the ODA received (in %) in Colombia and ODA received (in %) in Oman?
Offer a terse response. -1.15. In the year 1994, what is the difference between the ODA received (in %) in Jamaica and ODA received (in %) in Oman?
Provide a short and direct response. 1.21. In the year 1995, what is the difference between the ODA received (in %) of Brunei Darussalam and ODA received (in %) of Colombia?
Offer a terse response. -0.1. In the year 1995, what is the difference between the ODA received (in %) in Brunei Darussalam and ODA received (in %) in Jamaica?
Keep it short and to the point. -1.86. In the year 1995, what is the difference between the ODA received (in %) of Brunei Darussalam and ODA received (in %) of Oman?
Make the answer very short. -0.47. In the year 1995, what is the difference between the ODA received (in %) in Colombia and ODA received (in %) in Jamaica?
Your response must be concise. -1.76. In the year 1995, what is the difference between the ODA received (in %) in Colombia and ODA received (in %) in Oman?
Provide a short and direct response. -0.37. In the year 1995, what is the difference between the ODA received (in %) of Jamaica and ODA received (in %) of Oman?
Make the answer very short. 1.39. What is the ratio of the ODA received (in %) of Brunei Darussalam in 1989 to that in 1990?
Provide a succinct answer. 1.39. What is the ratio of the ODA received (in %) in Colombia in 1989 to that in 1990?
Keep it short and to the point. 0.77. What is the ratio of the ODA received (in %) of Oman in 1989 to that in 1990?
Offer a terse response. 0.45. What is the ratio of the ODA received (in %) in Brunei Darussalam in 1989 to that in 1991?
Offer a very short reply. 1.56. What is the ratio of the ODA received (in %) of Colombia in 1989 to that in 1991?
Provide a succinct answer. 0.62. What is the ratio of the ODA received (in %) of Jamaica in 1989 to that in 1991?
Your answer should be very brief. 1.48. What is the ratio of the ODA received (in %) in Oman in 1989 to that in 1991?
Your response must be concise. 2.31. What is the ratio of the ODA received (in %) of Brunei Darussalam in 1989 to that in 1992?
Ensure brevity in your answer.  1.19. What is the ratio of the ODA received (in %) in Colombia in 1989 to that in 1992?
Your answer should be compact. 0.37. What is the ratio of the ODA received (in %) of Jamaica in 1989 to that in 1992?
Your answer should be compact. 1.76. What is the ratio of the ODA received (in %) in Oman in 1989 to that in 1992?
Provide a succinct answer. 0.82. What is the ratio of the ODA received (in %) in Brunei Darussalam in 1989 to that in 1993?
Offer a terse response. 1.24. What is the ratio of the ODA received (in %) of Colombia in 1989 to that in 1993?
Provide a succinct answer. 1.16. What is the ratio of the ODA received (in %) of Jamaica in 1989 to that in 1993?
Give a very brief answer. 3.02. What is the ratio of the ODA received (in %) in Oman in 1989 to that in 1993?
Provide a short and direct response. 0.25. What is the ratio of the ODA received (in %) in Brunei Darussalam in 1989 to that in 1994?
Ensure brevity in your answer.  1.19. What is the ratio of the ODA received (in %) in Colombia in 1989 to that in 1994?
Provide a short and direct response. 1.94. What is the ratio of the ODA received (in %) in Jamaica in 1989 to that in 1994?
Provide a succinct answer. 2.63. What is the ratio of the ODA received (in %) in Oman in 1989 to that in 1994?
Provide a succinct answer. 0.22. What is the ratio of the ODA received (in %) of Brunei Darussalam in 1989 to that in 1995?
Provide a short and direct response. 1.69. What is the ratio of the ODA received (in %) of Colombia in 1989 to that in 1995?
Offer a very short reply. 0.97. What is the ratio of the ODA received (in %) in Jamaica in 1989 to that in 1995?
Make the answer very short. 3.32. What is the ratio of the ODA received (in %) in Oman in 1989 to that in 1995?
Your response must be concise. 0.48. What is the ratio of the ODA received (in %) of Brunei Darussalam in 1990 to that in 1991?
Your answer should be very brief. 1.13. What is the ratio of the ODA received (in %) of Colombia in 1990 to that in 1991?
Give a very brief answer. 0.81. What is the ratio of the ODA received (in %) in Jamaica in 1990 to that in 1991?
Provide a short and direct response. 1.49. What is the ratio of the ODA received (in %) in Oman in 1990 to that in 1991?
Offer a very short reply. 5.11. What is the ratio of the ODA received (in %) of Brunei Darussalam in 1990 to that in 1992?
Offer a terse response. 0.86. What is the ratio of the ODA received (in %) in Colombia in 1990 to that in 1992?
Make the answer very short. 0.47. What is the ratio of the ODA received (in %) of Jamaica in 1990 to that in 1992?
Your answer should be very brief. 1.78. What is the ratio of the ODA received (in %) in Oman in 1990 to that in 1992?
Offer a very short reply. 1.82. What is the ratio of the ODA received (in %) in Brunei Darussalam in 1990 to that in 1993?
Provide a short and direct response. 0.89. What is the ratio of the ODA received (in %) of Colombia in 1990 to that in 1993?
Give a very brief answer. 1.5. What is the ratio of the ODA received (in %) in Jamaica in 1990 to that in 1993?
Make the answer very short. 3.05. What is the ratio of the ODA received (in %) in Oman in 1990 to that in 1993?
Your answer should be compact. 0.56. What is the ratio of the ODA received (in %) of Brunei Darussalam in 1990 to that in 1994?
Offer a terse response. 0.86. What is the ratio of the ODA received (in %) of Colombia in 1990 to that in 1994?
Keep it short and to the point. 2.5. What is the ratio of the ODA received (in %) in Jamaica in 1990 to that in 1994?
Give a very brief answer. 2.65. What is the ratio of the ODA received (in %) in Oman in 1990 to that in 1994?
Keep it short and to the point. 0.48. What is the ratio of the ODA received (in %) of Brunei Darussalam in 1990 to that in 1995?
Your response must be concise. 1.22. What is the ratio of the ODA received (in %) in Colombia in 1990 to that in 1995?
Give a very brief answer. 1.25. What is the ratio of the ODA received (in %) in Jamaica in 1990 to that in 1995?
Offer a very short reply. 3.34. What is the ratio of the ODA received (in %) in Oman in 1990 to that in 1995?
Your answer should be compact. 1.07. What is the ratio of the ODA received (in %) in Brunei Darussalam in 1991 to that in 1992?
Provide a short and direct response. 0.76. What is the ratio of the ODA received (in %) in Colombia in 1991 to that in 1992?
Your answer should be very brief. 0.59. What is the ratio of the ODA received (in %) in Jamaica in 1991 to that in 1992?
Offer a terse response. 1.19. What is the ratio of the ODA received (in %) in Oman in 1991 to that in 1992?
Your answer should be very brief. 0.36. What is the ratio of the ODA received (in %) of Brunei Darussalam in 1991 to that in 1993?
Give a very brief answer. 0.79. What is the ratio of the ODA received (in %) of Colombia in 1991 to that in 1993?
Make the answer very short. 1.86. What is the ratio of the ODA received (in %) in Jamaica in 1991 to that in 1993?
Provide a succinct answer. 2.04. What is the ratio of the ODA received (in %) in Oman in 1991 to that in 1993?
Provide a succinct answer. 0.11. What is the ratio of the ODA received (in %) in Brunei Darussalam in 1991 to that in 1994?
Offer a terse response. 0.76. What is the ratio of the ODA received (in %) in Colombia in 1991 to that in 1994?
Offer a very short reply. 3.1. What is the ratio of the ODA received (in %) in Jamaica in 1991 to that in 1994?
Provide a succinct answer. 1.78. What is the ratio of the ODA received (in %) of Oman in 1991 to that in 1994?
Your answer should be very brief. 0.09. What is the ratio of the ODA received (in %) of Brunei Darussalam in 1991 to that in 1995?
Your answer should be compact. 1.08. What is the ratio of the ODA received (in %) of Colombia in 1991 to that in 1995?
Your answer should be very brief. 1.55. What is the ratio of the ODA received (in %) in Jamaica in 1991 to that in 1995?
Keep it short and to the point. 2.24. What is the ratio of the ODA received (in %) in Oman in 1991 to that in 1995?
Make the answer very short. 0.21. What is the ratio of the ODA received (in %) in Brunei Darussalam in 1992 to that in 1993?
Your response must be concise. 1.04. What is the ratio of the ODA received (in %) in Colombia in 1992 to that in 1993?
Make the answer very short. 3.17. What is the ratio of the ODA received (in %) in Jamaica in 1992 to that in 1993?
Keep it short and to the point. 1.71. What is the ratio of the ODA received (in %) in Oman in 1992 to that in 1993?
Provide a succinct answer. 0.31. What is the ratio of the ODA received (in %) in Colombia in 1992 to that in 1994?
Provide a short and direct response. 5.29. What is the ratio of the ODA received (in %) of Jamaica in 1992 to that in 1994?
Give a very brief answer. 1.49. What is the ratio of the ODA received (in %) in Oman in 1992 to that in 1994?
Give a very brief answer. 0.26. What is the ratio of the ODA received (in %) of Brunei Darussalam in 1992 to that in 1995?
Your answer should be compact. 1.42. What is the ratio of the ODA received (in %) in Colombia in 1992 to that in 1995?
Give a very brief answer. 2.64. What is the ratio of the ODA received (in %) in Jamaica in 1992 to that in 1995?
Make the answer very short. 1.88. What is the ratio of the ODA received (in %) of Oman in 1992 to that in 1995?
Provide a succinct answer. 0.59. What is the ratio of the ODA received (in %) in Brunei Darussalam in 1993 to that in 1994?
Keep it short and to the point. 0.96. What is the ratio of the ODA received (in %) of Colombia in 1993 to that in 1994?
Give a very brief answer. 1.67. What is the ratio of the ODA received (in %) in Jamaica in 1993 to that in 1994?
Provide a short and direct response. 0.87. What is the ratio of the ODA received (in %) in Oman in 1993 to that in 1994?
Keep it short and to the point. 0.86. What is the ratio of the ODA received (in %) of Brunei Darussalam in 1993 to that in 1995?
Ensure brevity in your answer.  1.36. What is the ratio of the ODA received (in %) in Colombia in 1993 to that in 1995?
Your answer should be very brief. 0.83. What is the ratio of the ODA received (in %) in Jamaica in 1993 to that in 1995?
Your response must be concise. 1.1. What is the ratio of the ODA received (in %) in Oman in 1993 to that in 1995?
Offer a terse response. 1.91. What is the ratio of the ODA received (in %) of Brunei Darussalam in 1994 to that in 1995?
Your answer should be very brief. 1.42. What is the ratio of the ODA received (in %) in Colombia in 1994 to that in 1995?
Provide a succinct answer. 0.5. What is the ratio of the ODA received (in %) of Jamaica in 1994 to that in 1995?
Your answer should be very brief. 1.26. What is the ratio of the ODA received (in %) of Oman in 1994 to that in 1995?
Make the answer very short. 2.22. What is the difference between the highest and the second highest ODA received (in %) in Brunei Darussalam?
Provide a succinct answer. 0.02. What is the difference between the highest and the second highest ODA received (in %) of Colombia?
Provide a short and direct response. 0.2. What is the difference between the highest and the second highest ODA received (in %) of Jamaica?
Your response must be concise. 0.06. What is the difference between the highest and the second highest ODA received (in %) of Oman?
Give a very brief answer. 0.17. What is the difference between the highest and the lowest ODA received (in %) in Brunei Darussalam?
Your response must be concise. 0.06. What is the difference between the highest and the lowest ODA received (in %) in Colombia?
Offer a very short reply. 0.4. What is the difference between the highest and the lowest ODA received (in %) in Jamaica?
Offer a very short reply. 4.56. What is the difference between the highest and the lowest ODA received (in %) of Oman?
Offer a very short reply. 1.13. 